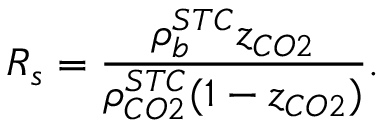Convert formula to latex. <formula><loc_0><loc_0><loc_500><loc_500>R _ { s } = \frac { \rho _ { b } ^ { S T C } z _ { C O 2 } } { \rho _ { C O 2 } ^ { S T C } ( 1 - z _ { C O 2 } ) } .</formula> 